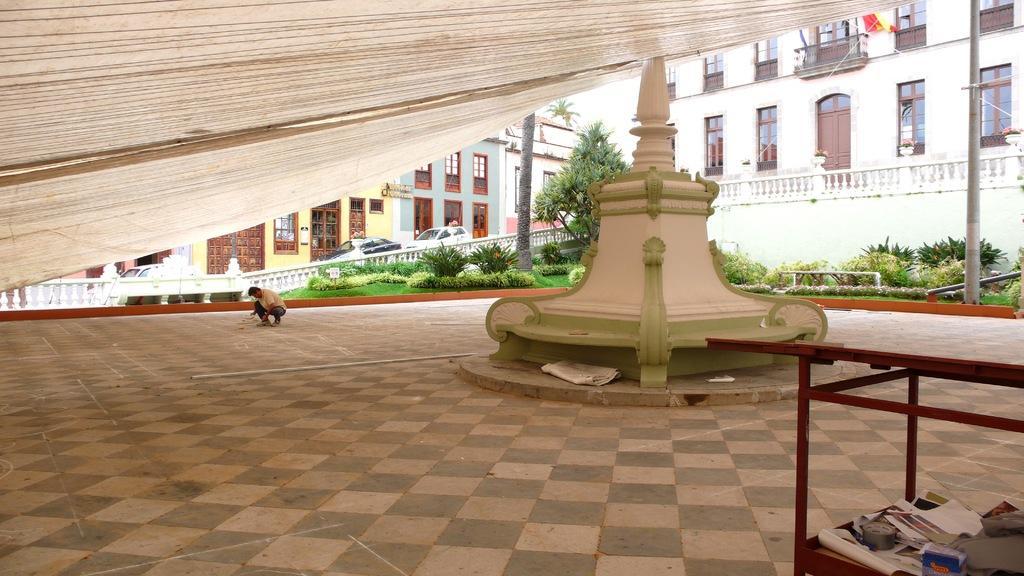How would you summarize this image in a sentence or two? This image consists of a man in squatting position. At the bottom, there is a floor. In the background, there are buildings and cars parked on the road. In the front, there is a tree along with the grass on the ground. To the right, there is a table. At the top, there is a cloth in white color. 